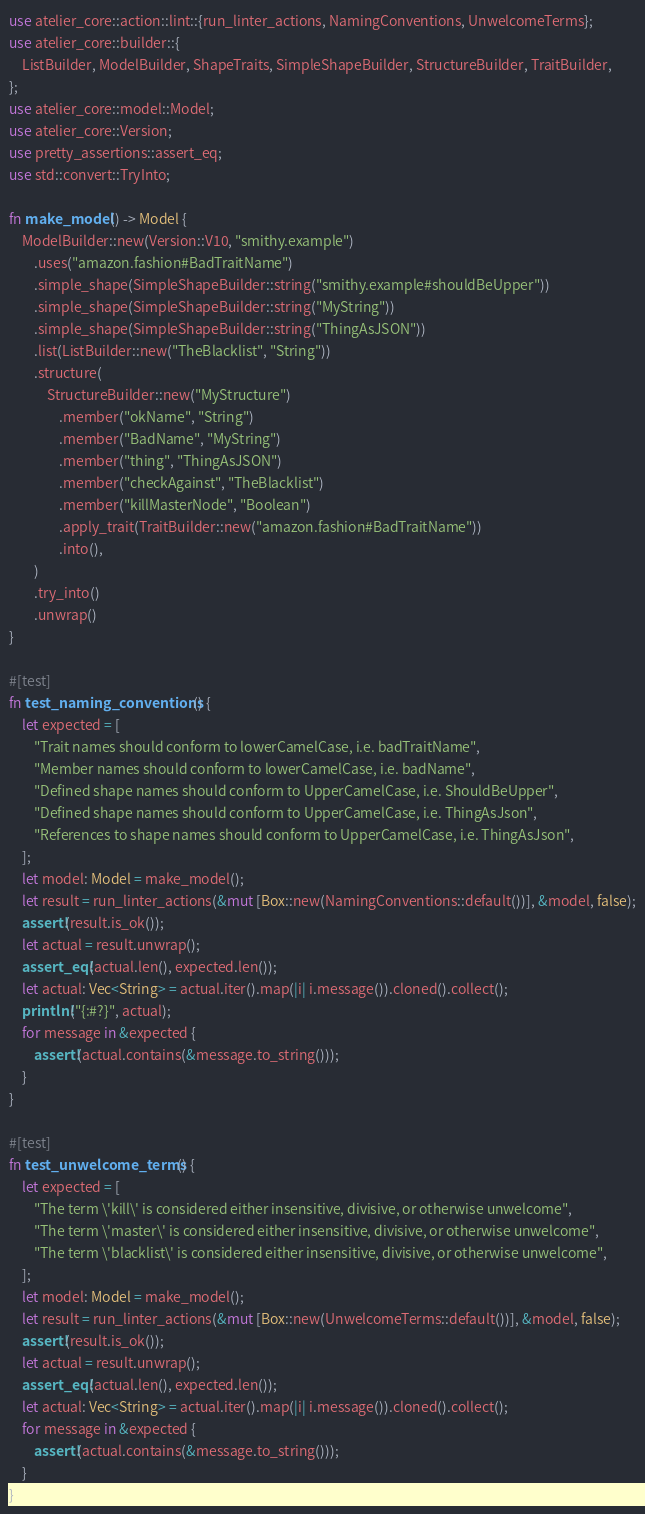<code> <loc_0><loc_0><loc_500><loc_500><_Rust_>use atelier_core::action::lint::{run_linter_actions, NamingConventions, UnwelcomeTerms};
use atelier_core::builder::{
    ListBuilder, ModelBuilder, ShapeTraits, SimpleShapeBuilder, StructureBuilder, TraitBuilder,
};
use atelier_core::model::Model;
use atelier_core::Version;
use pretty_assertions::assert_eq;
use std::convert::TryInto;

fn make_model() -> Model {
    ModelBuilder::new(Version::V10, "smithy.example")
        .uses("amazon.fashion#BadTraitName")
        .simple_shape(SimpleShapeBuilder::string("smithy.example#shouldBeUpper"))
        .simple_shape(SimpleShapeBuilder::string("MyString"))
        .simple_shape(SimpleShapeBuilder::string("ThingAsJSON"))
        .list(ListBuilder::new("TheBlacklist", "String"))
        .structure(
            StructureBuilder::new("MyStructure")
                .member("okName", "String")
                .member("BadName", "MyString")
                .member("thing", "ThingAsJSON")
                .member("checkAgainst", "TheBlacklist")
                .member("killMasterNode", "Boolean")
                .apply_trait(TraitBuilder::new("amazon.fashion#BadTraitName"))
                .into(),
        )
        .try_into()
        .unwrap()
}

#[test]
fn test_naming_conventions() {
    let expected = [
        "Trait names should conform to lowerCamelCase, i.e. badTraitName",
        "Member names should conform to lowerCamelCase, i.e. badName",
        "Defined shape names should conform to UpperCamelCase, i.e. ShouldBeUpper",
        "Defined shape names should conform to UpperCamelCase, i.e. ThingAsJson",
        "References to shape names should conform to UpperCamelCase, i.e. ThingAsJson",
    ];
    let model: Model = make_model();
    let result = run_linter_actions(&mut [Box::new(NamingConventions::default())], &model, false);
    assert!(result.is_ok());
    let actual = result.unwrap();
    assert_eq!(actual.len(), expected.len());
    let actual: Vec<String> = actual.iter().map(|i| i.message()).cloned().collect();
    println!("{:#?}", actual);
    for message in &expected {
        assert!(actual.contains(&message.to_string()));
    }
}

#[test]
fn test_unwelcome_terms() {
    let expected = [
        "The term \'kill\' is considered either insensitive, divisive, or otherwise unwelcome",
        "The term \'master\' is considered either insensitive, divisive, or otherwise unwelcome",
        "The term \'blacklist\' is considered either insensitive, divisive, or otherwise unwelcome",
    ];
    let model: Model = make_model();
    let result = run_linter_actions(&mut [Box::new(UnwelcomeTerms::default())], &model, false);
    assert!(result.is_ok());
    let actual = result.unwrap();
    assert_eq!(actual.len(), expected.len());
    let actual: Vec<String> = actual.iter().map(|i| i.message()).cloned().collect();
    for message in &expected {
        assert!(actual.contains(&message.to_string()));
    }
}
</code> 